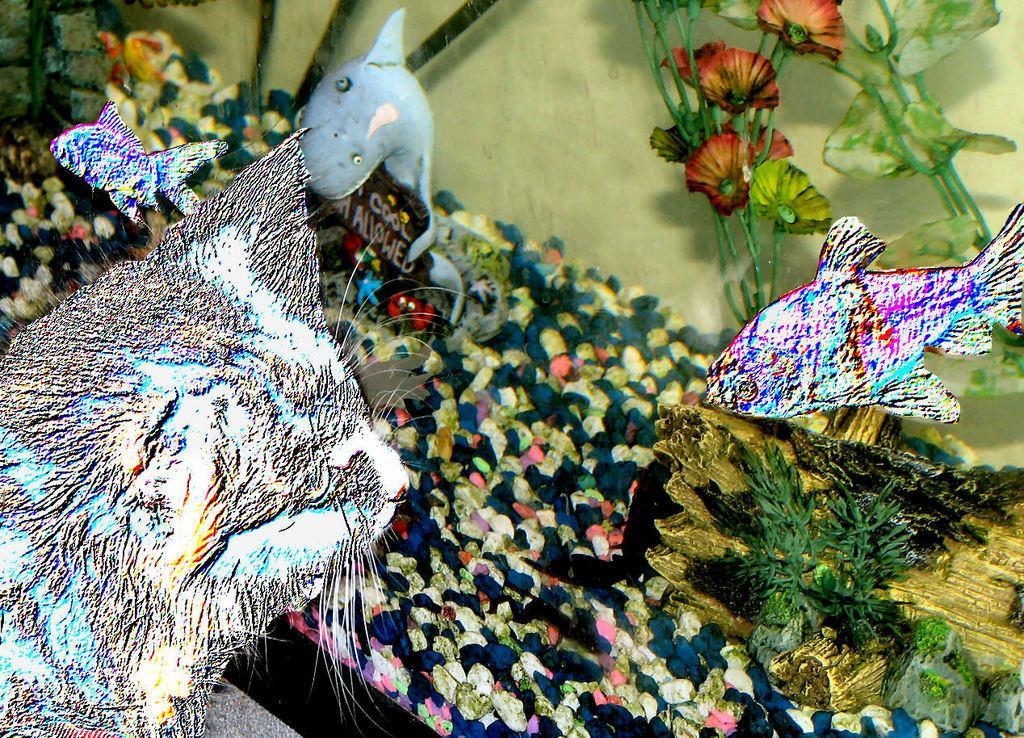How would you summarize this image in a sentence or two? This image consists of an aquarium. In which we can see the fishes and stones along with artificial plants. On the left, it looks like a cat. 